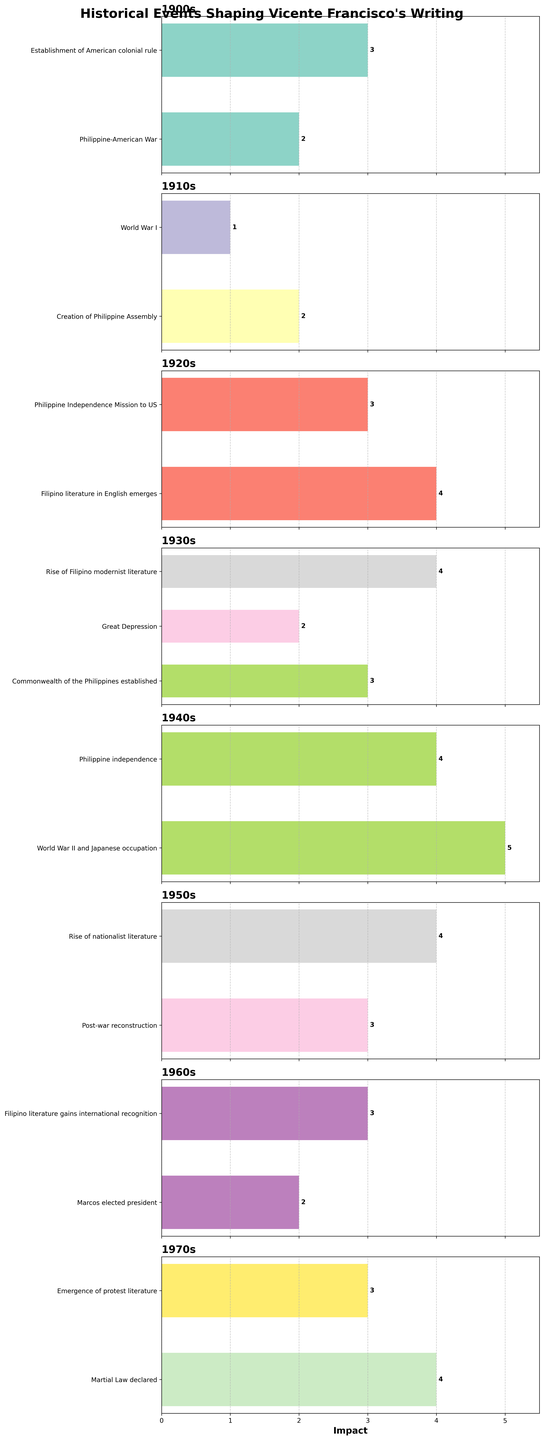Which decade had the highest overall impact on Vicente Francisco's writing? To determine the decade with the highest overall impact, we need to sum the impact values of each event within a decade and then compare the sums across all decades. Summing the impacts: 1900s: 2+3=5, 1910s: 2+1=3, 1920s: 4+3=7, 1930s: 3+2+4=9, 1940s: 5+4=9, 1950s: 3+4=7, 1960s: 2+3=5, 1970s: 4+3=7. The decades 1930s and 1940s both have the highest overall impact of 9.
Answer: 1930s and 1940s Which event had the highest impact in the 1940s? To find this, we examine the impact values for events in the 1940s. "World War II and Japanese occupation" has an impact of 5, while "Philippine independence" has an impact of 4. Hence, "World War II and Japanese occupation" has the highest impact.
Answer: World War II and Japanese occupation Was the impact of the Great Depression higher or lower than the rise of Filipino modernist literature in the 1930s? Comparing the two values in the 1930s, the impact of the Great Depression is 2 while the rise of Filipino modernist literature is 4. Therefore, the impact of the Great Depression was lower.
Answer: Lower How many events in the 1970s had an impact level of 4? The events and their impacts in the 1970s are "Martial Law declared" with an impact of 4 and "Emergence of protest literature" with an impact of 3. Only "Martial Law declared" has an impact level of 4. There is 1 event with an impact level of 4.
Answer: 1 What is the combined impact of events related to World Wars (World War I and World War II) on Vicente Francisco's writing? Summing the impact values related to World Wars: World War I (1) and World War II (5). Adding these together, 1 + 5 = 6. The combined impact is 6.
Answer: 6 Which decade(s) had the least total impact, and what was the total? To find the decade(s) with the least total impact, we sum the impact values for each decade. 1900s: 5, 1910s: 3, 1920s: 7, 1930s: 9, 1940s: 9, 1950s: 7, 1960s: 5, 1970s: 7. The 1910s have the least total impact with a sum of 3.
Answer: 1910s, 3 How does the impact of "Philippine Independence Mission to US" in the 1920s compare to "Philippine independence" in the 1940s? "Philippine Independence Mission to US" in the 1920s has an impact value of 3. "Philippine independence" in the 1940s has an impact value of 4. Therefore, "Philippine independence" has a higher impact.
Answer: Philippine independence is higher What is the average impact of the events in the 1950s? We sum the impact values of the events in the 1950s, "Post-war reconstruction" (3) and "Rise of nationalist literature" (4), and then divide by the number of events: (3 + 4) / 2 = 7 / 2 = 3.5. The average impact is 3.5.
Answer: 3.5 Which events had an impact level equal to or greater than 3 in the 1960s, and what are they? Assessing the events in the 1960s, "Marcos elected president" has an impact of 2, and "Filipino literature gains international recognition" has an impact of 3. Therefore, "Filipino literature gains international recognition" has an impact equal to or greater than 3.
Answer: Filipino literature gains international recognition What is the difference in impact between the "Post-war reconstruction" in the 1950s and "Martial Law declared" in the 1970s? The impact of "Post-war reconstruction" in the 1950s is 3, and the impact of "Martial Law declared" in the 1970s is 4. The difference is 4 - 3 = 1.
Answer: 1 